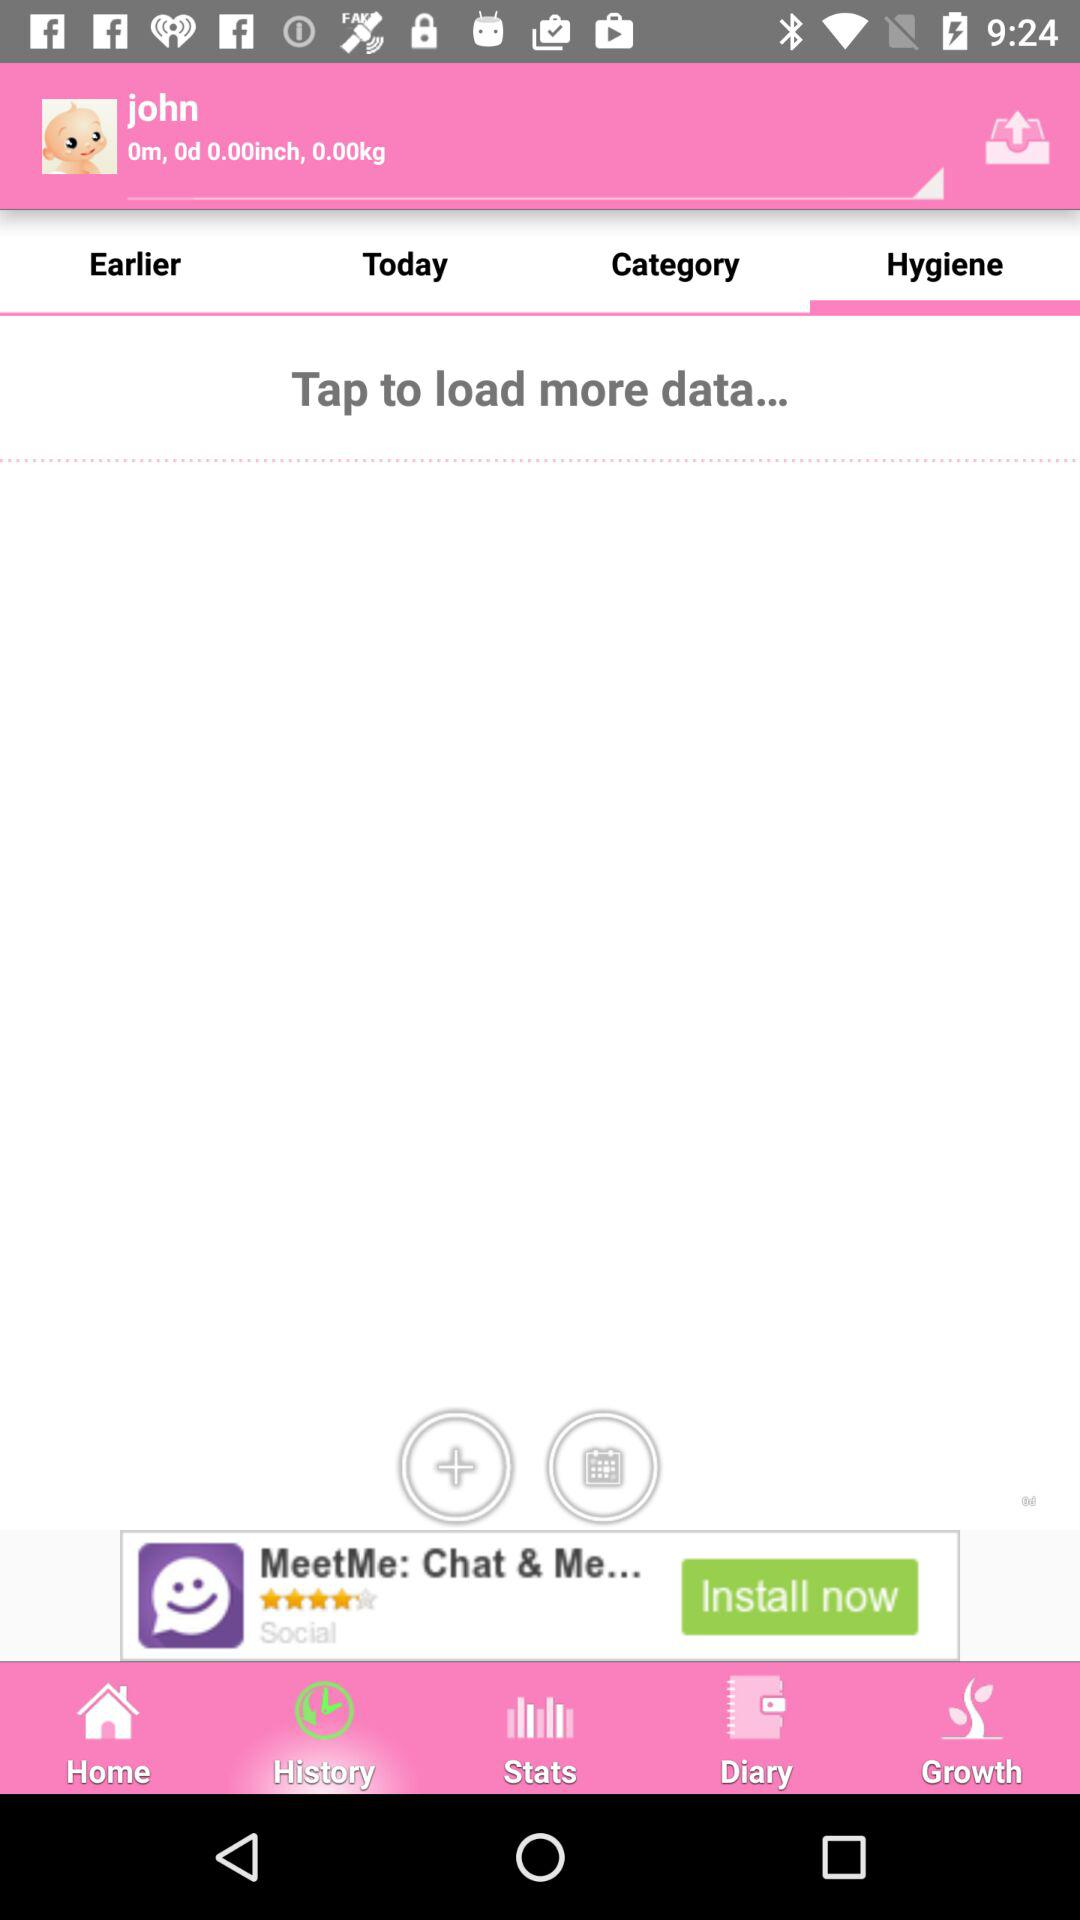What is the weight? The weight is 0.00kg. 